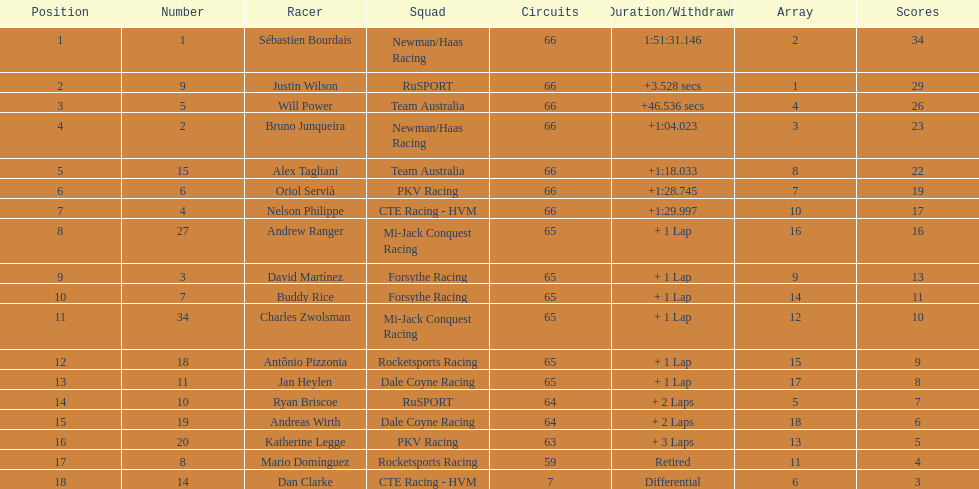At the 2006 gran premio telmex, who scored the highest number of points? Sébastien Bourdais. 